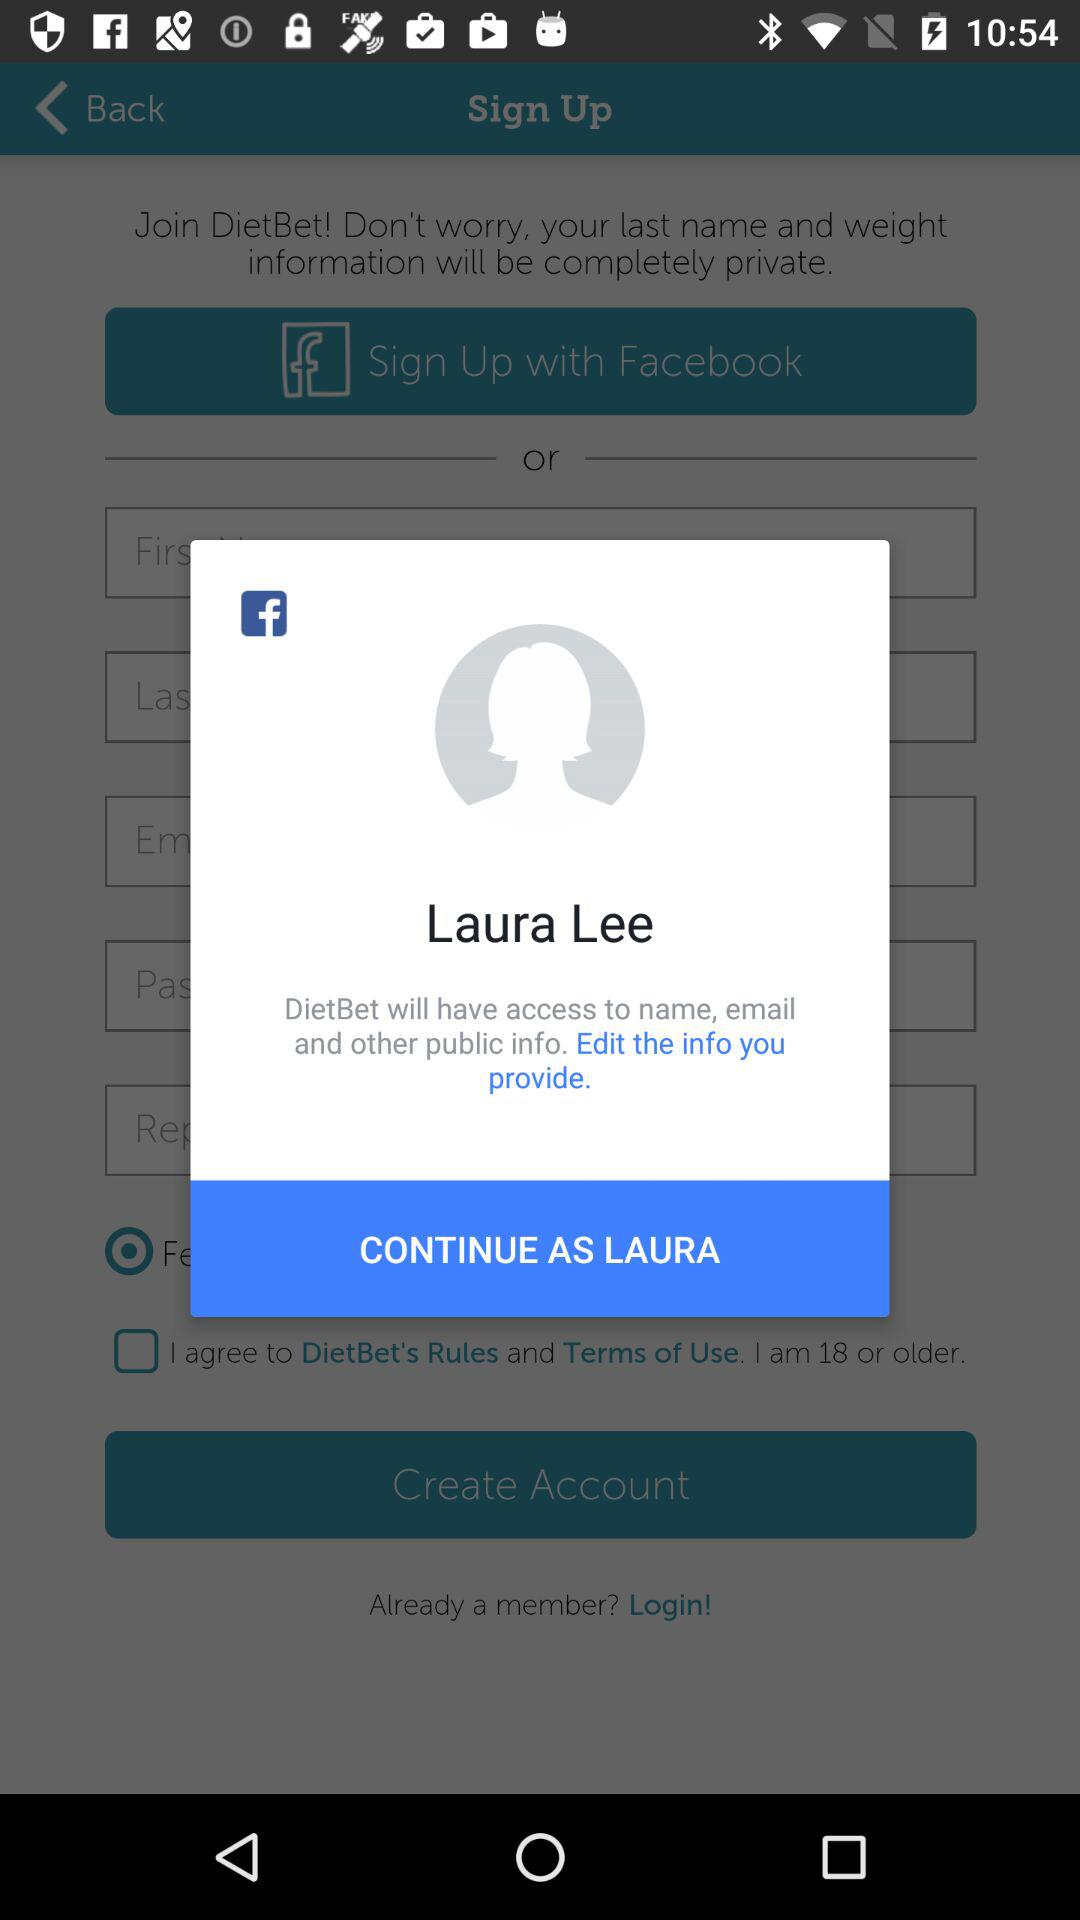How many public information items does DietBet have access to?
Answer the question using a single word or phrase. 3 